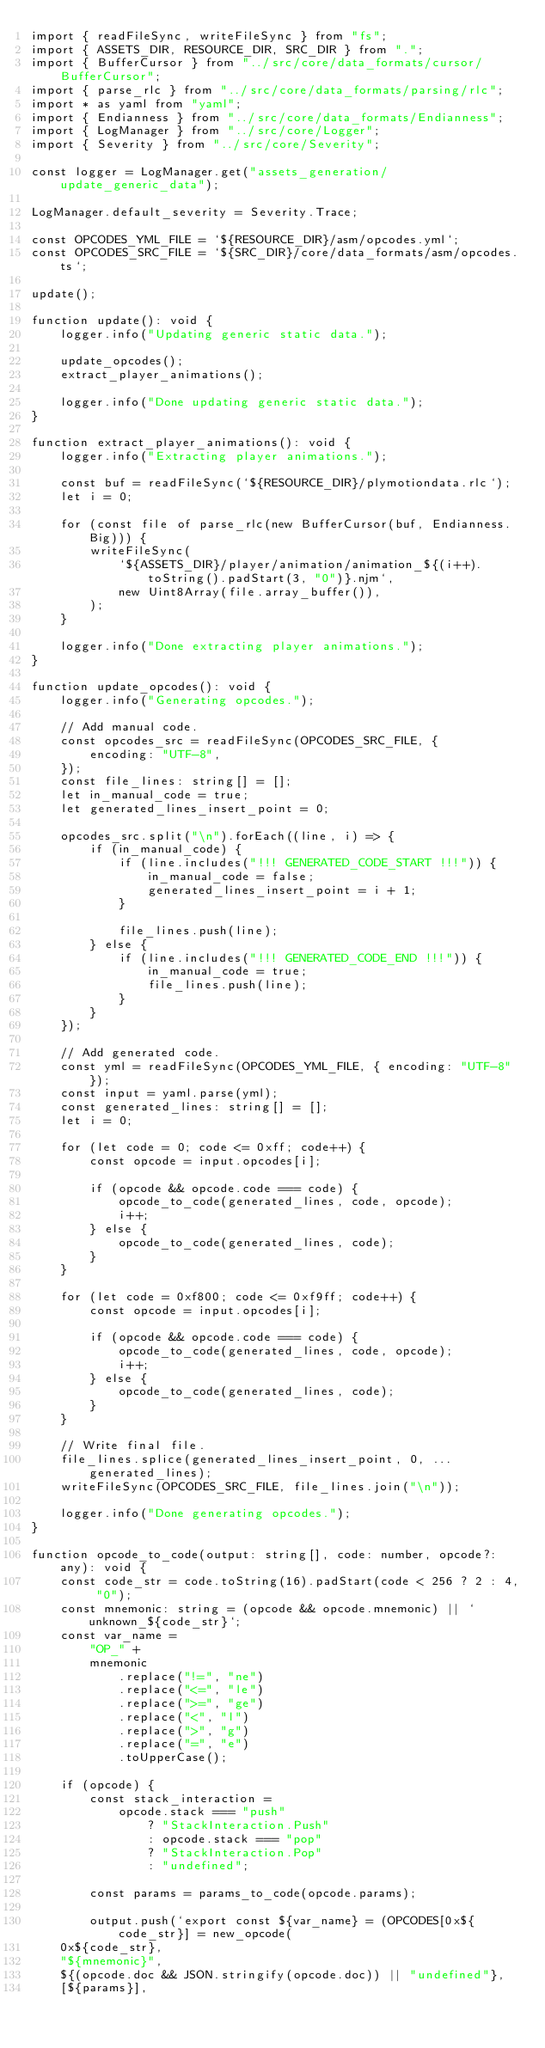<code> <loc_0><loc_0><loc_500><loc_500><_TypeScript_>import { readFileSync, writeFileSync } from "fs";
import { ASSETS_DIR, RESOURCE_DIR, SRC_DIR } from ".";
import { BufferCursor } from "../src/core/data_formats/cursor/BufferCursor";
import { parse_rlc } from "../src/core/data_formats/parsing/rlc";
import * as yaml from "yaml";
import { Endianness } from "../src/core/data_formats/Endianness";
import { LogManager } from "../src/core/Logger";
import { Severity } from "../src/core/Severity";

const logger = LogManager.get("assets_generation/update_generic_data");

LogManager.default_severity = Severity.Trace;

const OPCODES_YML_FILE = `${RESOURCE_DIR}/asm/opcodes.yml`;
const OPCODES_SRC_FILE = `${SRC_DIR}/core/data_formats/asm/opcodes.ts`;

update();

function update(): void {
    logger.info("Updating generic static data.");

    update_opcodes();
    extract_player_animations();

    logger.info("Done updating generic static data.");
}

function extract_player_animations(): void {
    logger.info("Extracting player animations.");

    const buf = readFileSync(`${RESOURCE_DIR}/plymotiondata.rlc`);
    let i = 0;

    for (const file of parse_rlc(new BufferCursor(buf, Endianness.Big))) {
        writeFileSync(
            `${ASSETS_DIR}/player/animation/animation_${(i++).toString().padStart(3, "0")}.njm`,
            new Uint8Array(file.array_buffer()),
        );
    }

    logger.info("Done extracting player animations.");
}

function update_opcodes(): void {
    logger.info("Generating opcodes.");

    // Add manual code.
    const opcodes_src = readFileSync(OPCODES_SRC_FILE, {
        encoding: "UTF-8",
    });
    const file_lines: string[] = [];
    let in_manual_code = true;
    let generated_lines_insert_point = 0;

    opcodes_src.split("\n").forEach((line, i) => {
        if (in_manual_code) {
            if (line.includes("!!! GENERATED_CODE_START !!!")) {
                in_manual_code = false;
                generated_lines_insert_point = i + 1;
            }

            file_lines.push(line);
        } else {
            if (line.includes("!!! GENERATED_CODE_END !!!")) {
                in_manual_code = true;
                file_lines.push(line);
            }
        }
    });

    // Add generated code.
    const yml = readFileSync(OPCODES_YML_FILE, { encoding: "UTF-8" });
    const input = yaml.parse(yml);
    const generated_lines: string[] = [];
    let i = 0;

    for (let code = 0; code <= 0xff; code++) {
        const opcode = input.opcodes[i];

        if (opcode && opcode.code === code) {
            opcode_to_code(generated_lines, code, opcode);
            i++;
        } else {
            opcode_to_code(generated_lines, code);
        }
    }

    for (let code = 0xf800; code <= 0xf9ff; code++) {
        const opcode = input.opcodes[i];

        if (opcode && opcode.code === code) {
            opcode_to_code(generated_lines, code, opcode);
            i++;
        } else {
            opcode_to_code(generated_lines, code);
        }
    }

    // Write final file.
    file_lines.splice(generated_lines_insert_point, 0, ...generated_lines);
    writeFileSync(OPCODES_SRC_FILE, file_lines.join("\n"));

    logger.info("Done generating opcodes.");
}

function opcode_to_code(output: string[], code: number, opcode?: any): void {
    const code_str = code.toString(16).padStart(code < 256 ? 2 : 4, "0");
    const mnemonic: string = (opcode && opcode.mnemonic) || `unknown_${code_str}`;
    const var_name =
        "OP_" +
        mnemonic
            .replace("!=", "ne")
            .replace("<=", "le")
            .replace(">=", "ge")
            .replace("<", "l")
            .replace(">", "g")
            .replace("=", "e")
            .toUpperCase();

    if (opcode) {
        const stack_interaction =
            opcode.stack === "push"
                ? "StackInteraction.Push"
                : opcode.stack === "pop"
                ? "StackInteraction.Pop"
                : "undefined";

        const params = params_to_code(opcode.params);

        output.push(`export const ${var_name} = (OPCODES[0x${code_str}] = new_opcode(
    0x${code_str},
    "${mnemonic}",
    ${(opcode.doc && JSON.stringify(opcode.doc)) || "undefined"},
    [${params}],</code> 